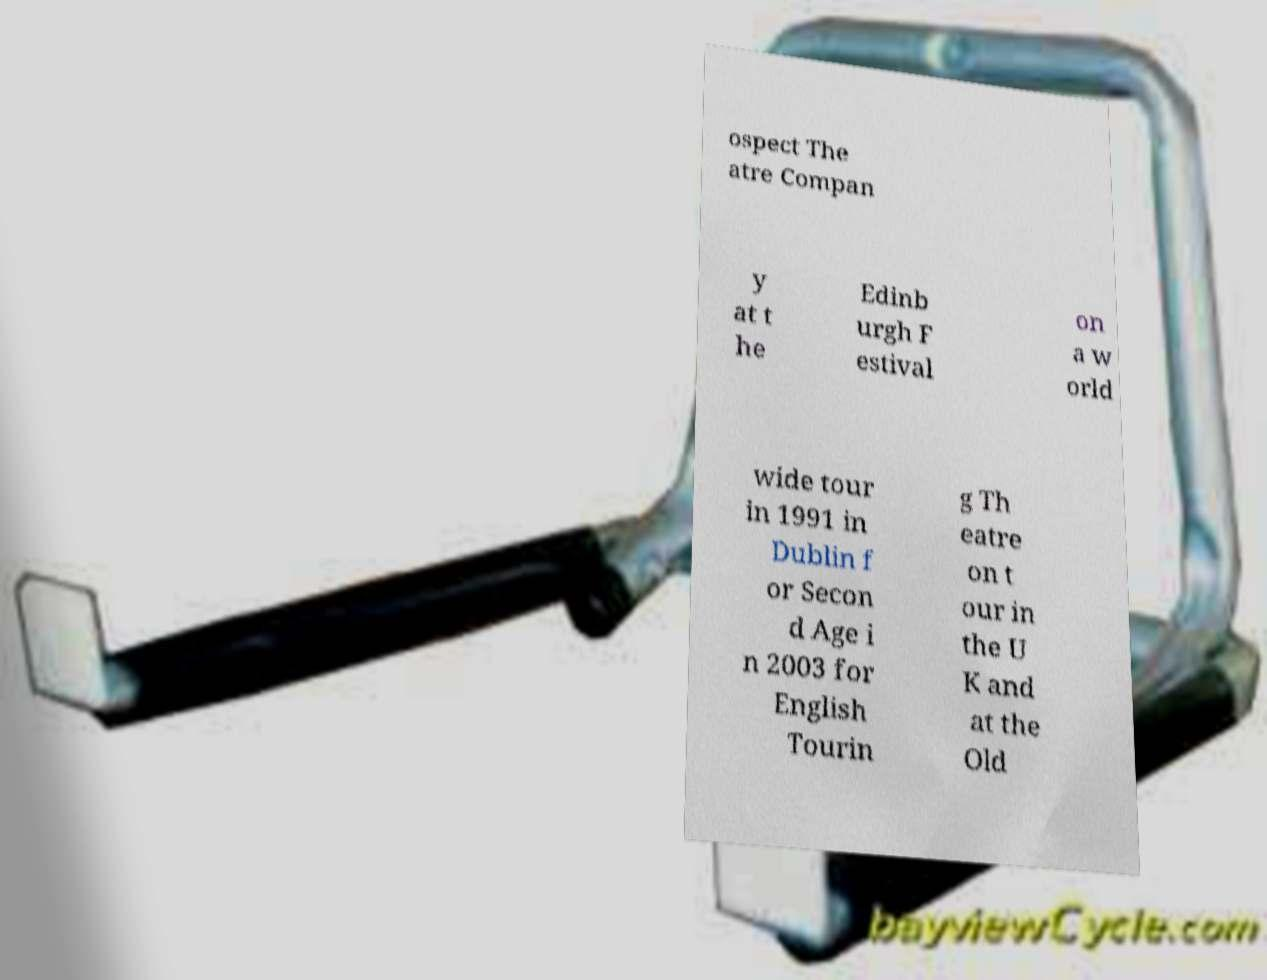For documentation purposes, I need the text within this image transcribed. Could you provide that? ospect The atre Compan y at t he Edinb urgh F estival on a w orld wide tour in 1991 in Dublin f or Secon d Age i n 2003 for English Tourin g Th eatre on t our in the U K and at the Old 